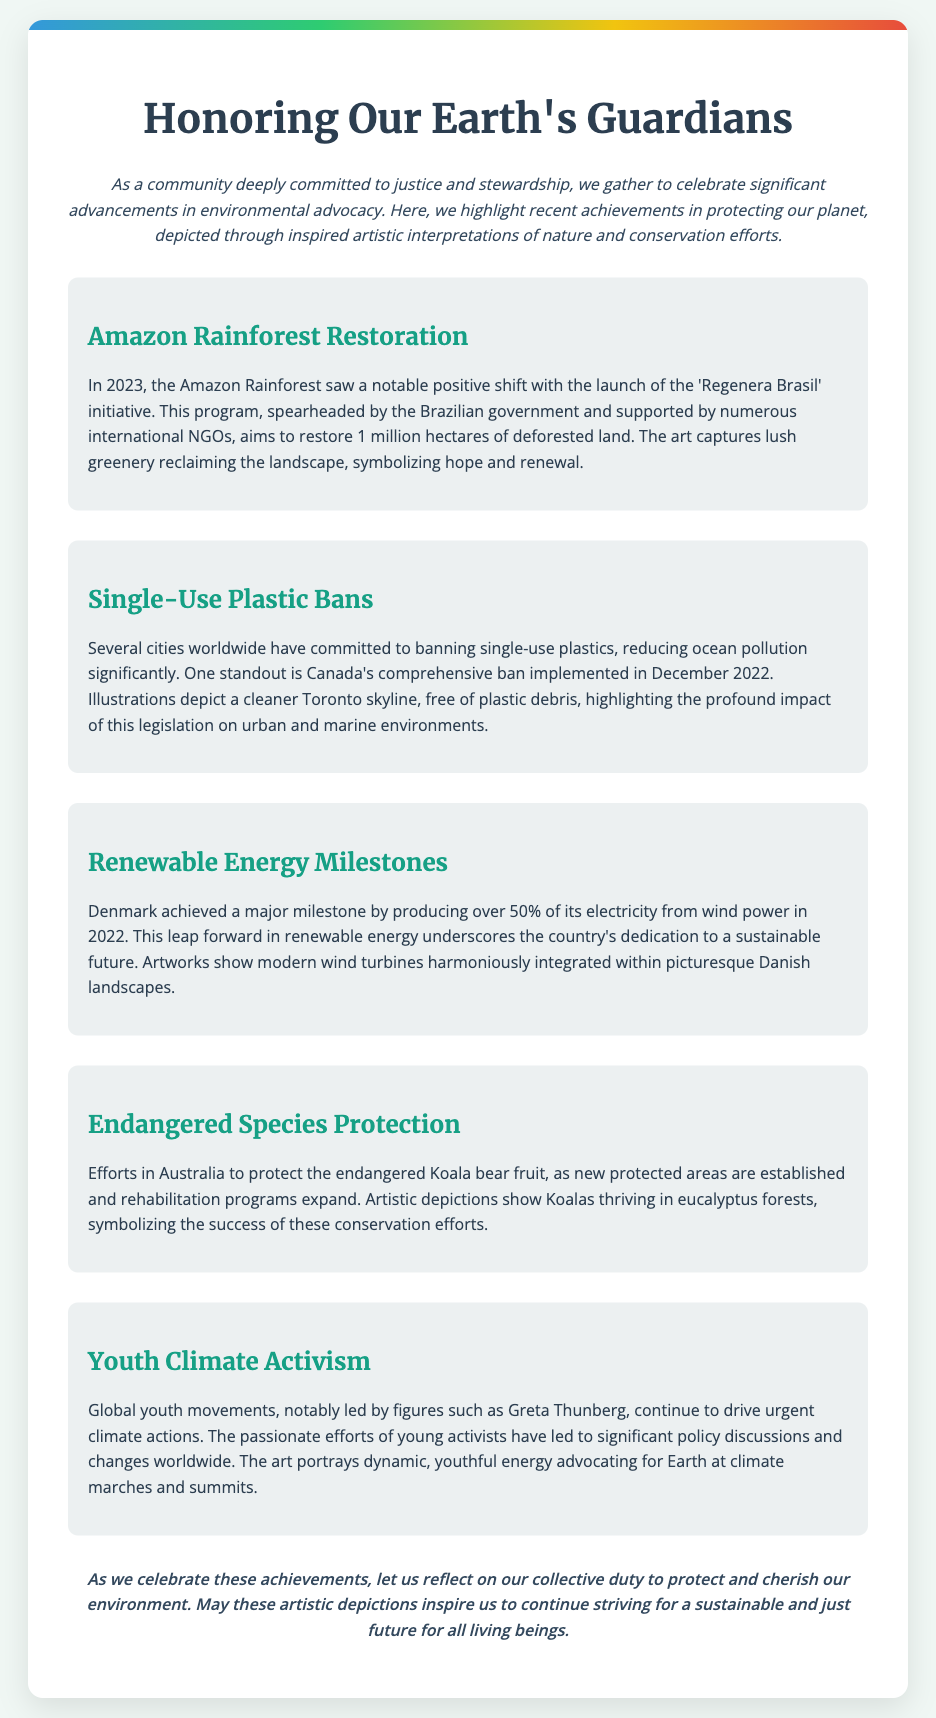What is the title of the card? The title is prominently displayed at the top of the card, indicating its theme.
Answer: Honoring Our Earth's Guardians What initiative is mentioned for Amazon Rainforest restoration? The card elaborates on a specific initiative aimed at restoring deforested land in the Amazon.
Answer: Regenera Brasil Which country achieved over 50% electricity from wind power? The document highlights a remarkable energy milestone from a specific nation in 2022.
Answer: Denmark What does the art depict in relation to single-use plastic bans? The illustrations specifically represent the urban environment's improvement following legislative changes.
Answer: A cleaner Toronto skyline Who is mentioned as a notable figure in youth climate activism? The text references an influential activist leading the global youth movement for climate awareness.
Answer: Greta Thunberg What is the purpose of the closing statement? The card ends with a reflective message about ongoing environmental responsibility, summarizing its goal.
Answer: To inspire environmental stewardship 